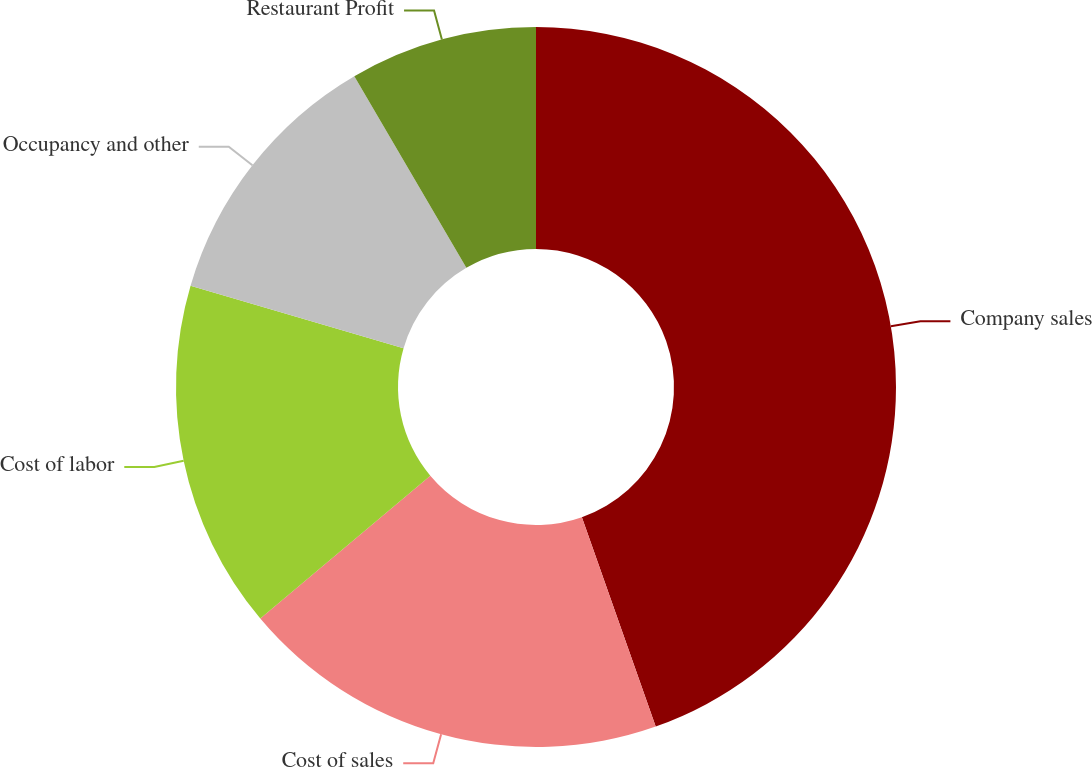Convert chart to OTSL. <chart><loc_0><loc_0><loc_500><loc_500><pie_chart><fcel>Company sales<fcel>Cost of sales<fcel>Cost of labor<fcel>Occupancy and other<fcel>Restaurant Profit<nl><fcel>44.61%<fcel>19.28%<fcel>15.66%<fcel>12.04%<fcel>8.42%<nl></chart> 